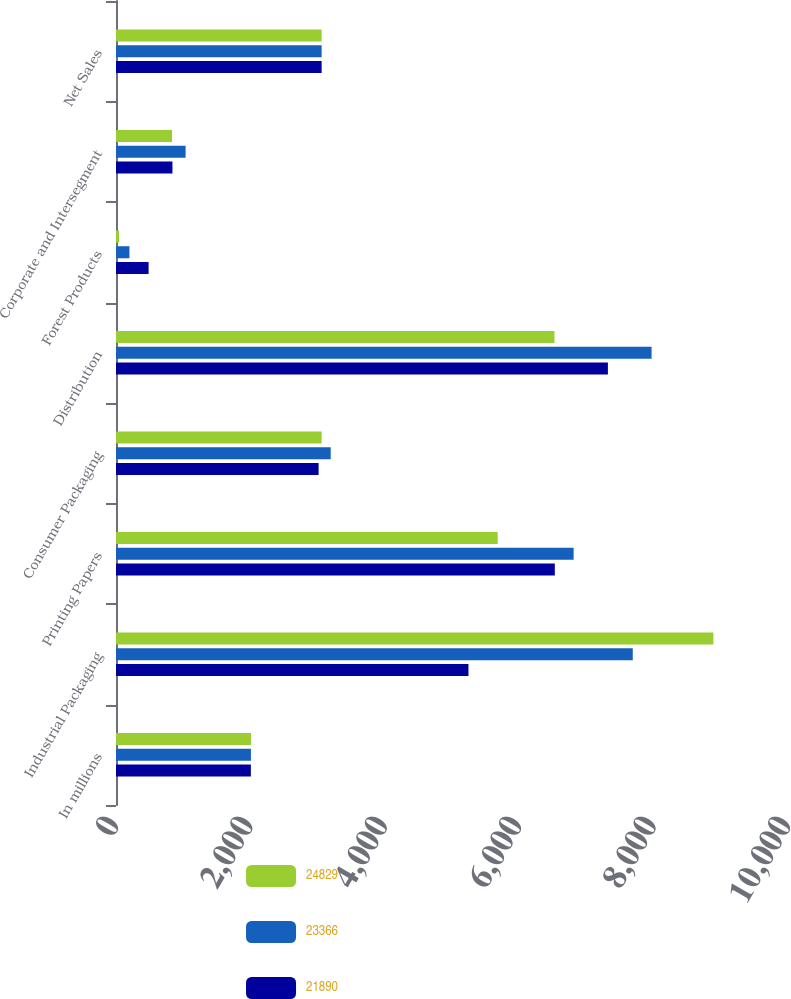Convert chart. <chart><loc_0><loc_0><loc_500><loc_500><stacked_bar_chart><ecel><fcel>In millions<fcel>Industrial Packaging<fcel>Printing Papers<fcel>Consumer Packaging<fcel>Distribution<fcel>Forest Products<fcel>Corporate and Intersegment<fcel>Net Sales<nl><fcel>24829<fcel>2009<fcel>8890<fcel>5680<fcel>3060<fcel>6525<fcel>45<fcel>834<fcel>3060<nl><fcel>23366<fcel>2008<fcel>7690<fcel>6810<fcel>3195<fcel>7970<fcel>200<fcel>1036<fcel>3060<nl><fcel>21890<fcel>2007<fcel>5245<fcel>6530<fcel>3015<fcel>7320<fcel>485<fcel>840<fcel>3060<nl></chart> 